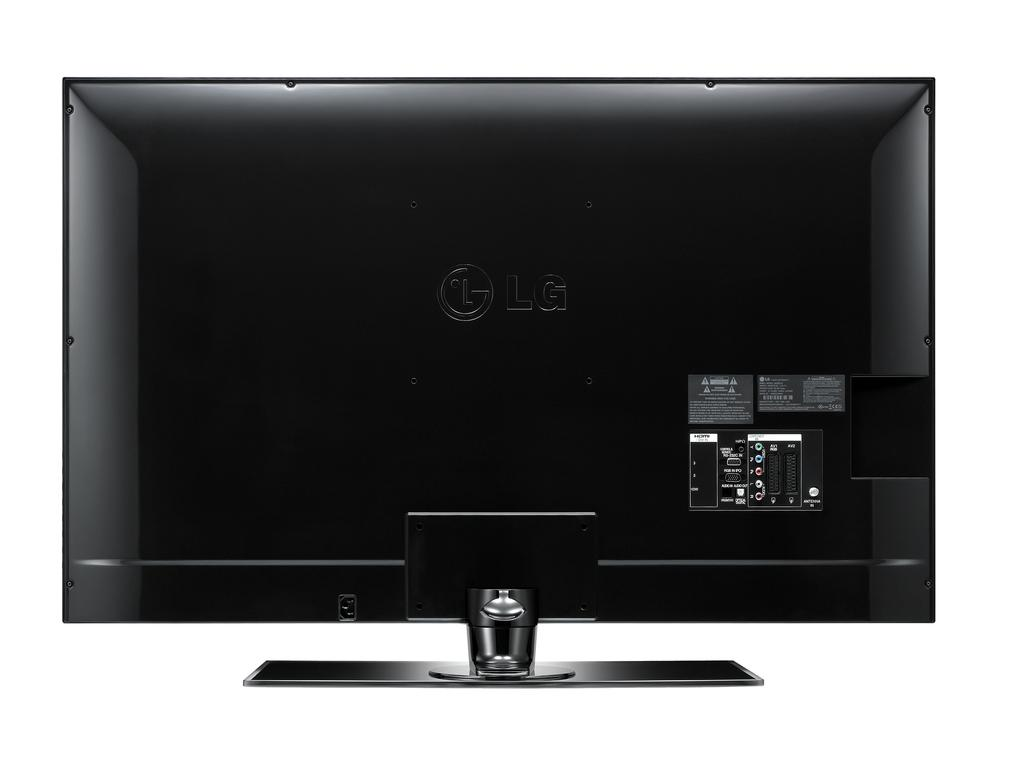What part of a television can be seen in the image? The back side of a television is visible in the image. Can you tell me how many family members are visible in the image? There are no family members present in the image; it only features the back side of a television. What type of expansion is shown happening to the television in the image? There is no expansion shown happening to the television in the image; it only shows the back side. What event related to death is depicted in the image? There is no event related to death depicted in the image; it only features the back side of a television. 